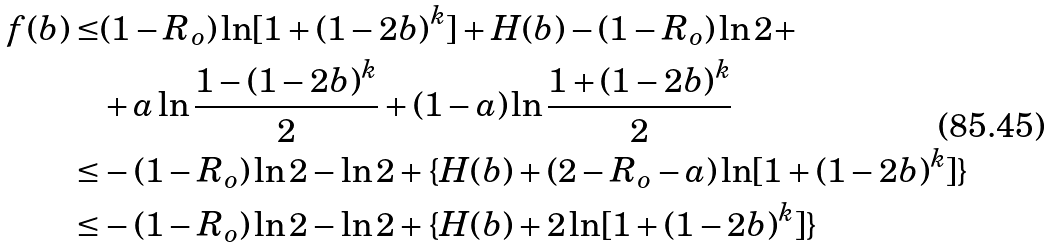Convert formula to latex. <formula><loc_0><loc_0><loc_500><loc_500>f ( b ) \leq & ( 1 - R _ { o } ) \ln [ 1 + ( 1 - 2 b ) ^ { k } ] + H ( b ) - ( 1 - R _ { o } ) \ln 2 + \\ & + a \ln \frac { 1 - ( 1 - 2 b ) ^ { k } } { 2 } + ( 1 - a ) \ln \frac { 1 + ( 1 - 2 b ) ^ { k } } { 2 } \\ \leq & - ( 1 - R _ { o } ) \ln 2 - \ln 2 + \{ H ( b ) + ( 2 - R _ { o } - a ) \ln [ 1 + ( 1 - 2 b ) ^ { k } ] \} \\ \leq & - ( 1 - R _ { o } ) \ln 2 - \ln 2 + \{ H ( b ) + 2 \ln [ 1 + ( 1 - 2 b ) ^ { k } ] \}</formula> 